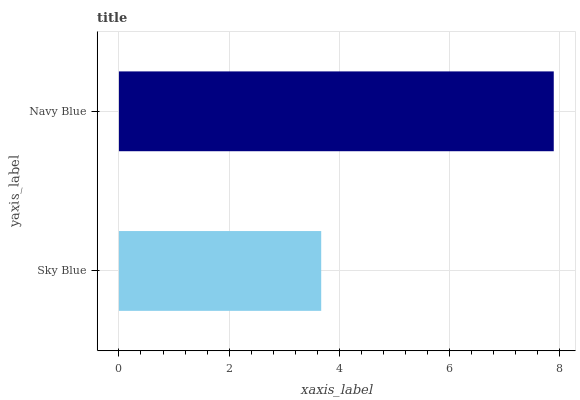Is Sky Blue the minimum?
Answer yes or no. Yes. Is Navy Blue the maximum?
Answer yes or no. Yes. Is Navy Blue the minimum?
Answer yes or no. No. Is Navy Blue greater than Sky Blue?
Answer yes or no. Yes. Is Sky Blue less than Navy Blue?
Answer yes or no. Yes. Is Sky Blue greater than Navy Blue?
Answer yes or no. No. Is Navy Blue less than Sky Blue?
Answer yes or no. No. Is Navy Blue the high median?
Answer yes or no. Yes. Is Sky Blue the low median?
Answer yes or no. Yes. Is Sky Blue the high median?
Answer yes or no. No. Is Navy Blue the low median?
Answer yes or no. No. 